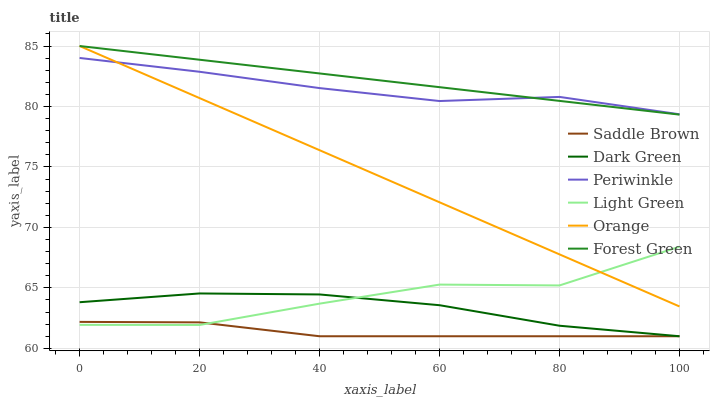Does Saddle Brown have the minimum area under the curve?
Answer yes or no. Yes. Does Forest Green have the maximum area under the curve?
Answer yes or no. Yes. Does Periwinkle have the minimum area under the curve?
Answer yes or no. No. Does Periwinkle have the maximum area under the curve?
Answer yes or no. No. Is Orange the smoothest?
Answer yes or no. Yes. Is Light Green the roughest?
Answer yes or no. Yes. Is Periwinkle the smoothest?
Answer yes or no. No. Is Periwinkle the roughest?
Answer yes or no. No. Does Saddle Brown have the lowest value?
Answer yes or no. Yes. Does Light Green have the lowest value?
Answer yes or no. No. Does Orange have the highest value?
Answer yes or no. Yes. Does Periwinkle have the highest value?
Answer yes or no. No. Is Dark Green less than Periwinkle?
Answer yes or no. Yes. Is Orange greater than Saddle Brown?
Answer yes or no. Yes. Does Forest Green intersect Periwinkle?
Answer yes or no. Yes. Is Forest Green less than Periwinkle?
Answer yes or no. No. Is Forest Green greater than Periwinkle?
Answer yes or no. No. Does Dark Green intersect Periwinkle?
Answer yes or no. No. 